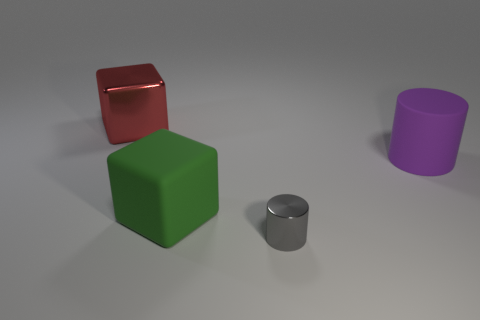Add 4 blue blocks. How many objects exist? 8 Subtract all gray shiny cylinders. Subtract all small rubber cylinders. How many objects are left? 3 Add 4 large green objects. How many large green objects are left? 5 Add 1 purple rubber things. How many purple rubber things exist? 2 Subtract 0 blue cylinders. How many objects are left? 4 Subtract 1 blocks. How many blocks are left? 1 Subtract all cyan cylinders. Subtract all brown cubes. How many cylinders are left? 2 